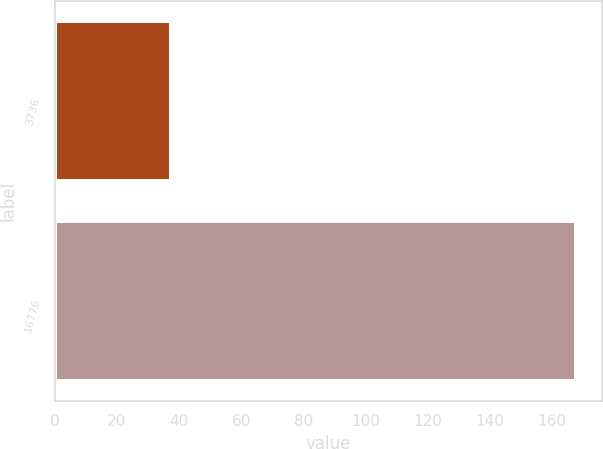Convert chart to OTSL. <chart><loc_0><loc_0><loc_500><loc_500><bar_chart><fcel>3736<fcel>16776<nl><fcel>37.36<fcel>167.76<nl></chart> 